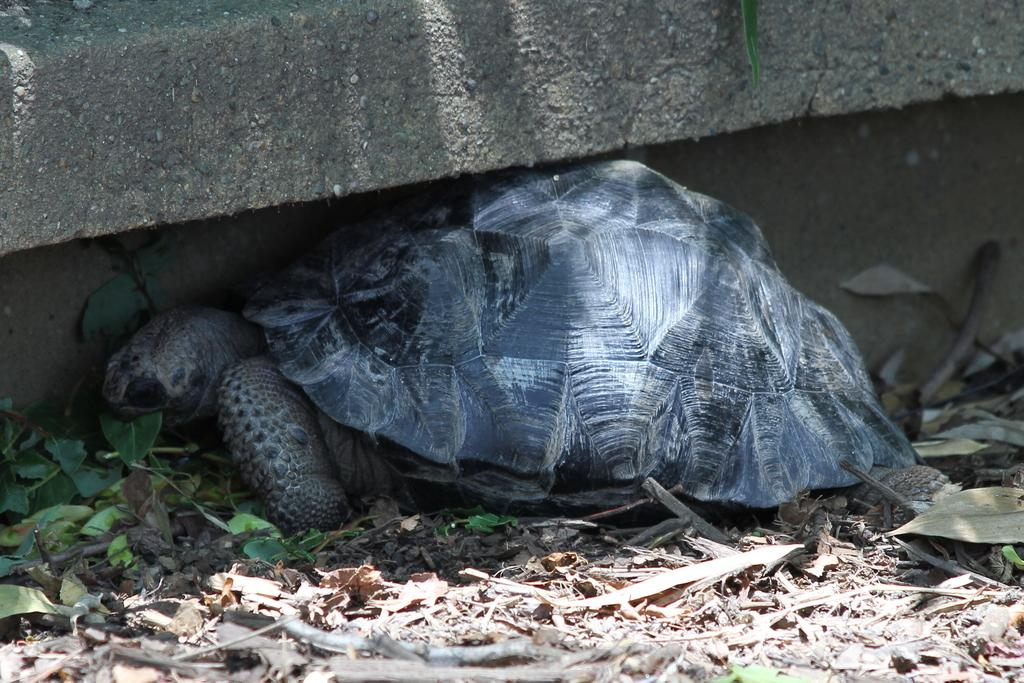What type of animal is in the image? There is a tortoise in the image. Where is the tortoise located? The tortoise is on the ground. What can be seen in the background of the image? There is a wall in the background of the image. What is the tortoise's opinion on the rail system in the image? There is no rail system present in the image, and tortoises do not have opinions. 